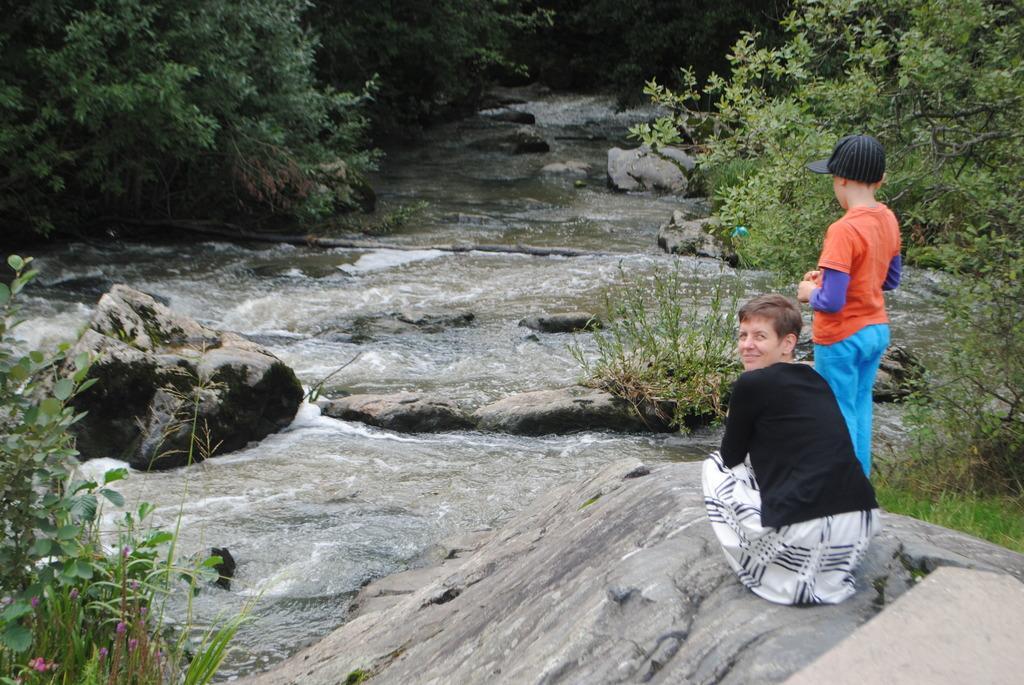Please provide a concise description of this image. In the picture we can see waterfalls on the rock surfaces and we can see one boy is sitting on the rock and smiling and turning behind and we can see another boy standing beside him and in the background we can see plants. 